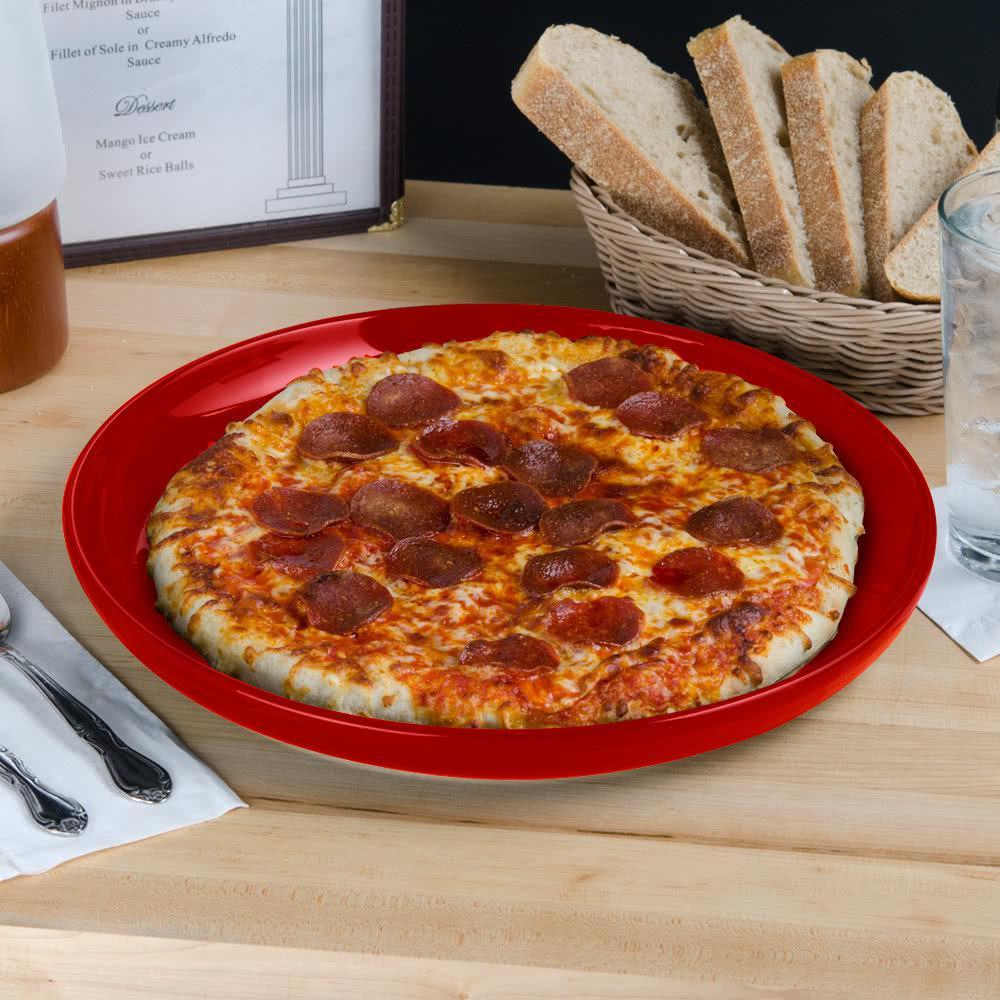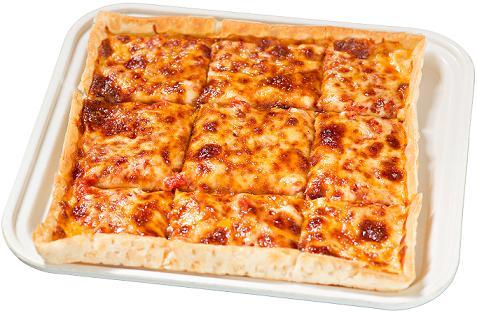The first image is the image on the left, the second image is the image on the right. Given the left and right images, does the statement "Each image shows a full round pizza." hold true? Answer yes or no. No. The first image is the image on the left, the second image is the image on the right. Assess this claim about the two images: "One of the pizzas has no other toppings but cheese.". Correct or not? Answer yes or no. Yes. 